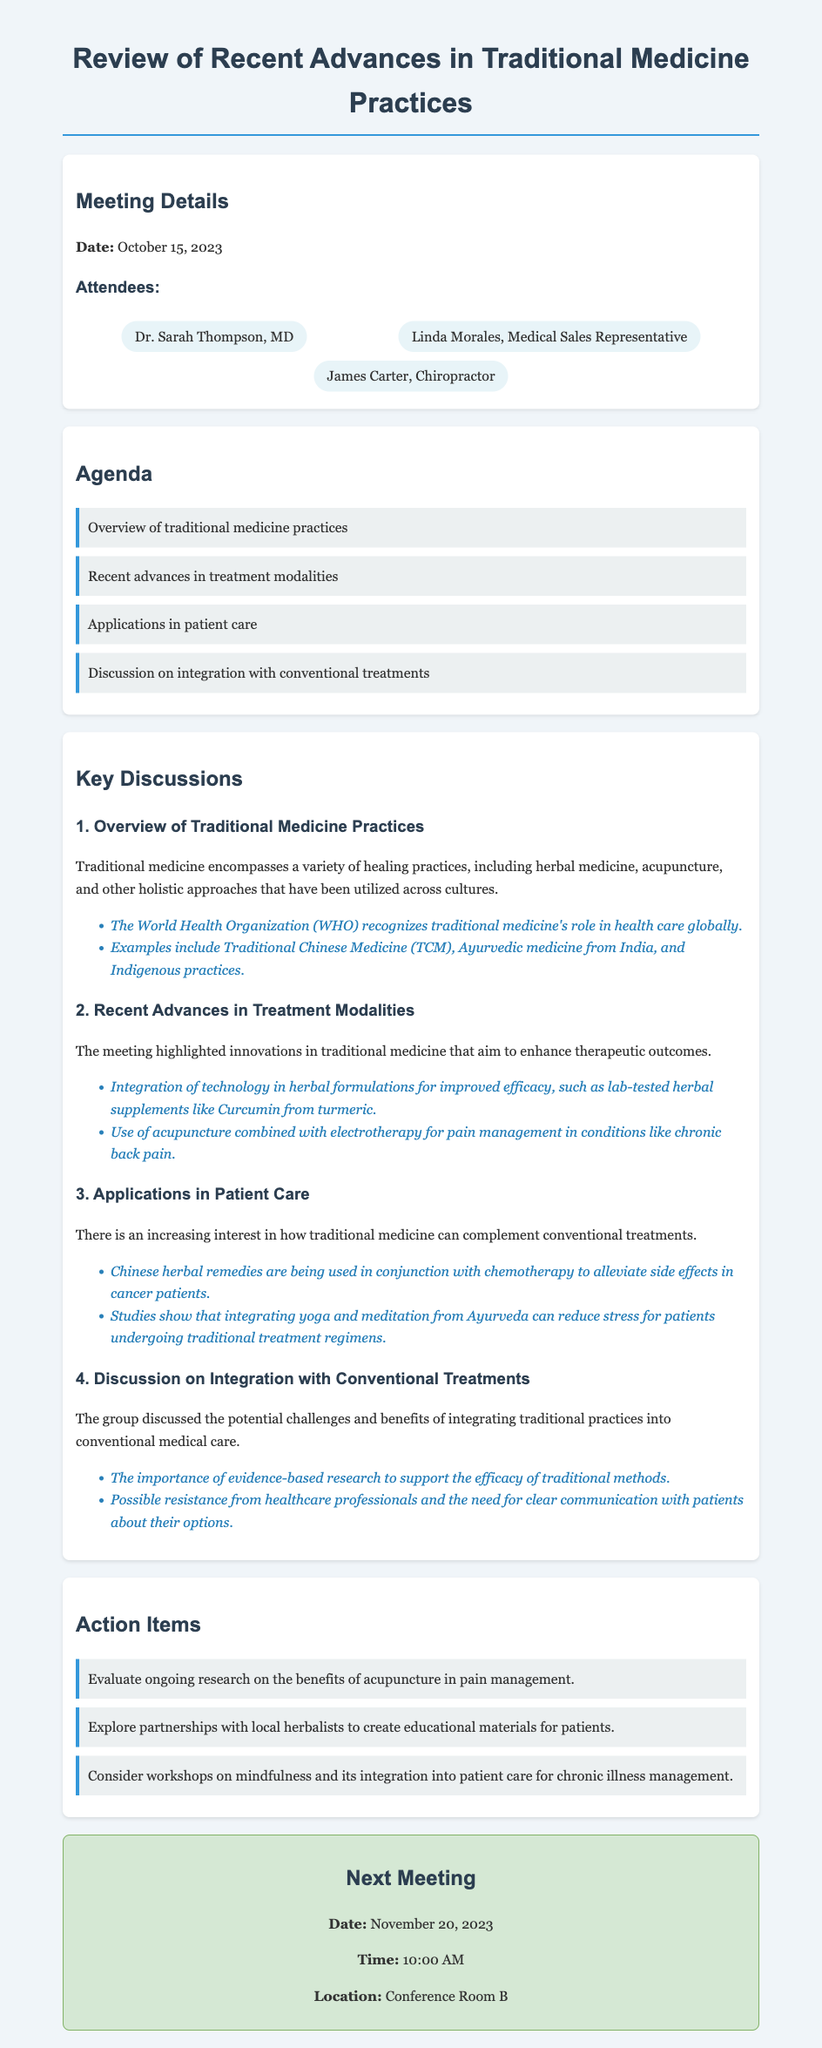What is the date of the meeting? The date of the meeting is mentioned in the document under Meeting Details.
Answer: October 15, 2023 Who is one of the attendees that works as a Medical Sales Representative? The attendees section lists individuals present at the meeting including their occupations.
Answer: Linda Morales What is one of the agenda items discussed? The agenda section outlines topics that were planned for discussion in the meeting.
Answer: Recent advances in treatment modalities What are Chinese herbal remedies used for in patient care? The applications section describes how traditional medicine is being used alongside conventional treatments.
Answer: Alleviate side effects in cancer patients What is an example of a recent advance in treatment modalities? The key discussions section highlights innovations in traditional medicine and their applications.
Answer: Use of acupuncture combined with electrotherapy for pain management What is a key point raised about integrating traditional practices? The discussion on integration section provides insights into the challenges and benefits discussed during the meeting.
Answer: Importance of evidence-based research When is the next meeting scheduled? The next meeting section specifies the date for the upcoming meeting.
Answer: November 20, 2023 Which doctor attended the meeting? The attendees section includes the names of doctors present at the meeting.
Answer: Dr. Sarah Thompson, MD 